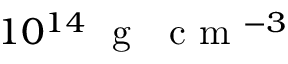Convert formula to latex. <formula><loc_0><loc_0><loc_500><loc_500>1 0 ^ { 1 4 } g c m ^ { - 3 }</formula> 